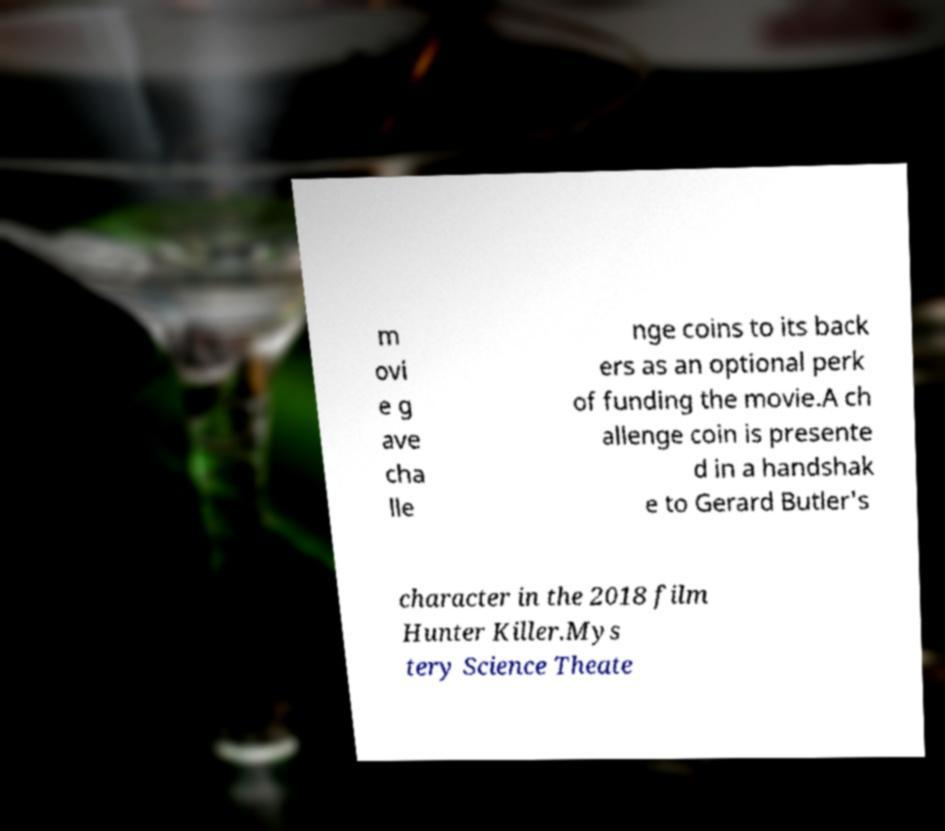Please read and relay the text visible in this image. What does it say? m ovi e g ave cha lle nge coins to its back ers as an optional perk of funding the movie.A ch allenge coin is presente d in a handshak e to Gerard Butler's character in the 2018 film Hunter Killer.Mys tery Science Theate 